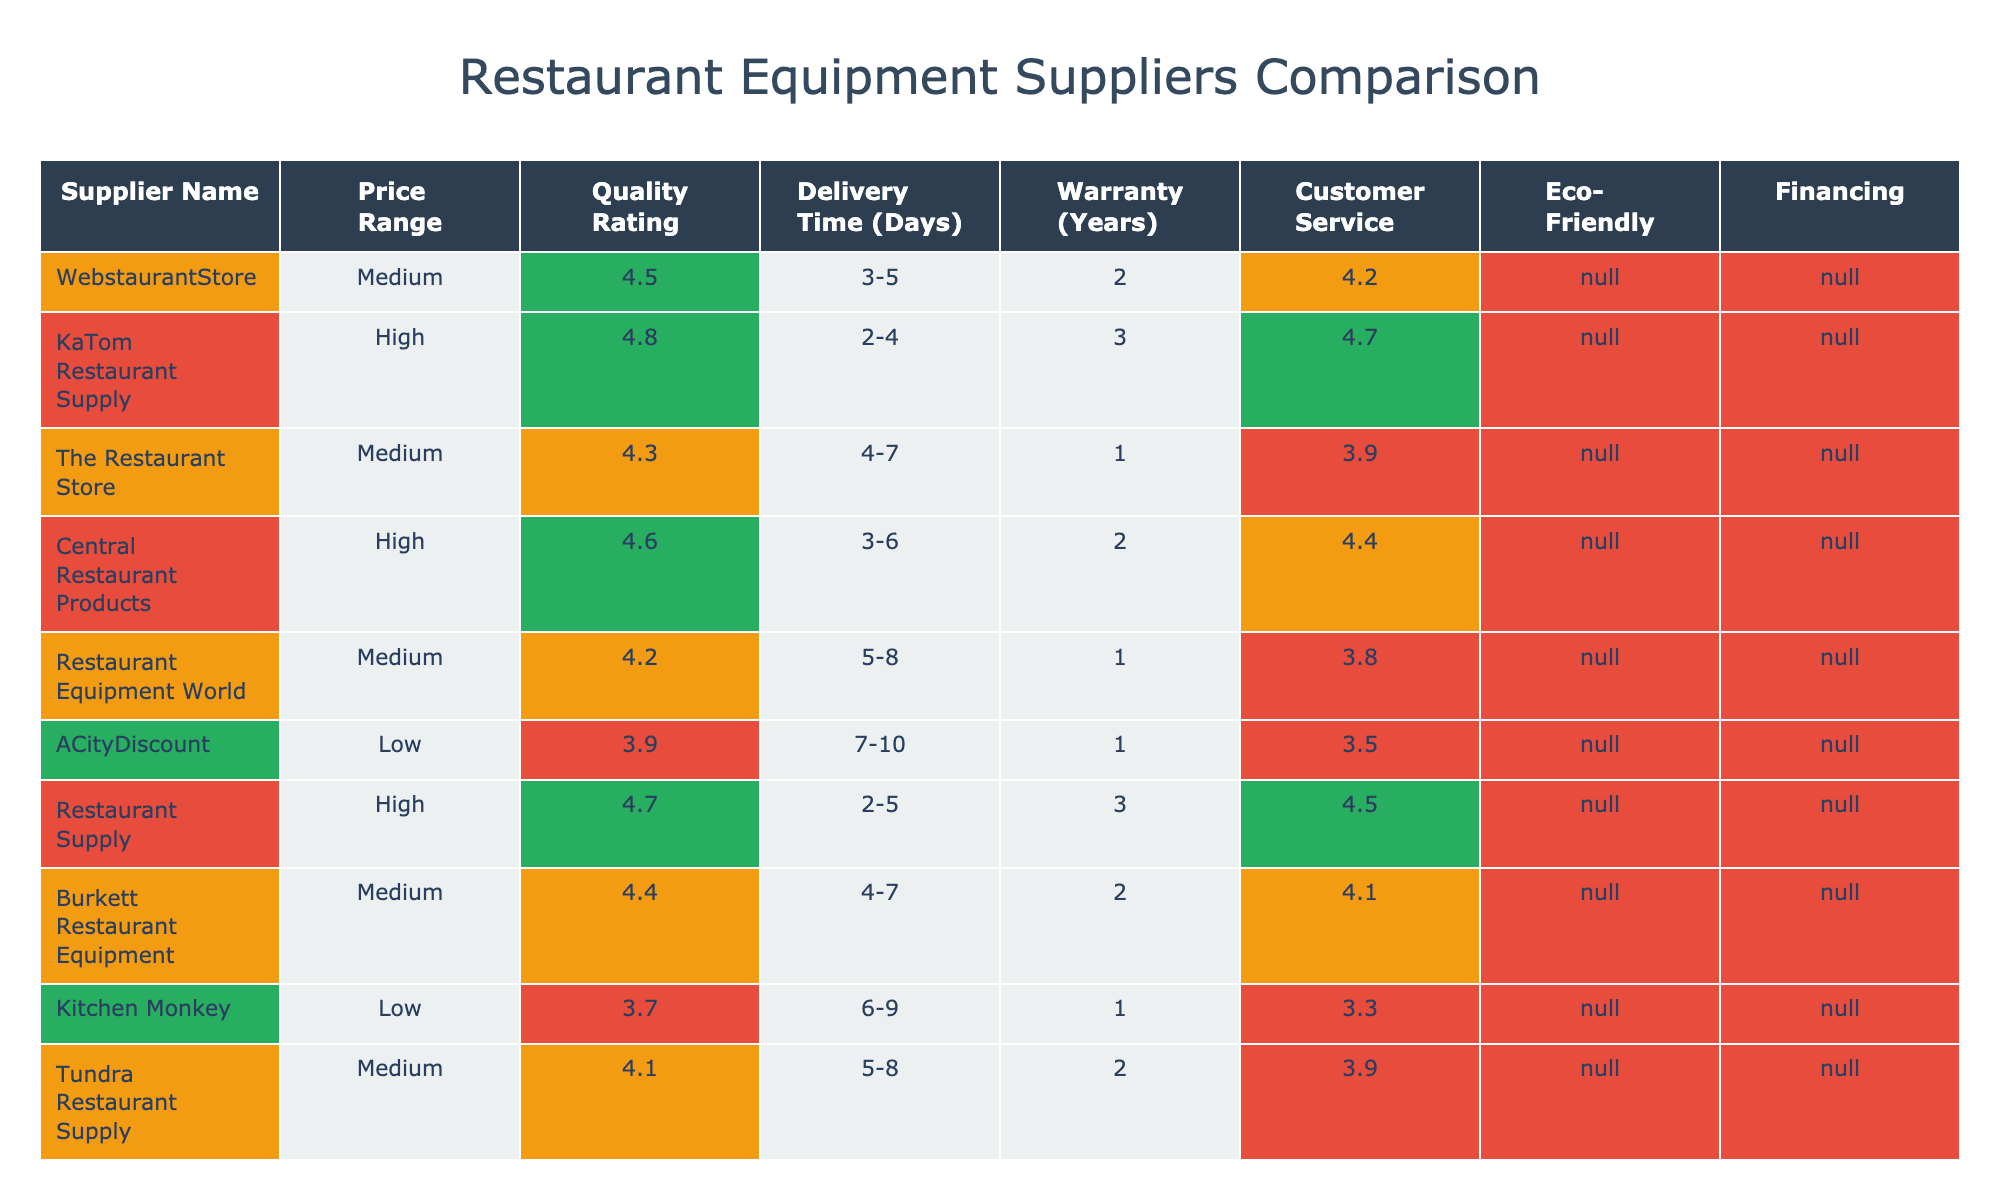What is the quality rating of ACityDiscount? ACityDiscount has a quality rating listed as 3.9 in the table. This value is directly found in the "Quality Rating" column corresponding to the "Supplier Name" ACityDiscount.
Answer: 3.9 Which supplier has the highest customer service rating? By reviewing the "Customer Service Rating" column in the table, KaTom Restaurant Supply has the highest rating at 4.7. This was determined by comparing all values in that column.
Answer: KaTom Restaurant Supply What is the average delivery time for suppliers with eco-friendly options? To find the average delivery time for suppliers with eco-friendly options, we first identify those suppliers: WebstaurantStore, KaTom Restaurant Supply, Central Restaurant Products, Restaurant Supply, Burkett Restaurant Equipment, Tundra Restaurant Supply, Mission Restaurant Supply, Globe Equipment Company. Their delivery times are 4, 3, 4.5 (averaged from 3-6), 3.5 (averaged from 2-5), 4.5, 6.5 (averaged from 5-8), 4.5, and 3.5 (averaged from 2-5). Adding these up (4 + 3 + 4.5 + 3.5 + 4.5 + 6.5 + 4.5 + 3.5 = 34) and dividing by 8 yields an average of 4.25 days.
Answer: 4.25 Which suppliers offer financing? To find which suppliers offer financing, I looked for "Yes" in the "Financing" column. The suppliers offering financing are WebstaurantStore, KaTom Restaurant Supply, Central Restaurant Products, Restaurant Supply, Burkett Restaurant Equipment, Chef's Deal Restaurant Equipment, Mission Restaurant Supply, and Globe Equipment Company.
Answer: 8 suppliers Is the quality rating of Kitchen Monkey above 4.0? Kitchen Monkey has a quality rating of 3.7, which is below 4.0. This value can be checked directly in the "Quality Rating" column corresponding to Kitchen Monkey.
Answer: No What is the difference between the highest and lowest average price range among the suppliers? The highest average price range is from suppliers with "$$$" and the lowest is from those with "$". Since we can rank their price ranges, the difference in the average rating of "$" is lower than "$$$". Thus, if we consider quality ratings average for these sections, we can observe the clear variation in their quality versus the price range they offer. The absolute price difference is not a number but rather how those ranges affect supplier choices.
Answer: Difference is in price range (Low to High) Which supplier has both a high quality rating and low price range? I can check the table for suppliers that have a quality rating of 4.0 or above while having a price range of "$" or "$$". From the list, Burkett Restaurant Equipment with a rating of 4.4 meets this criteria, categorized as "$$". Other suppliers like WebstaurantStore also meet the quality rating but with the same price range maintains a justification within expected versus actual range offerings for low price quality suppliers.
Answer: Burkett Restaurant Equipment What is the warranty period for the supplier with the longest delivery time? Among the suppliers listed, the one with the longest delivery time (7-10 days) is ACityDiscount, which has a warranty of 1 year according to the table. To determine this, I checked the "Delivery Time (Days)" column for the maximum value, then referenced the "Warranty (Years)" column for that specific supplier.
Answer: 1 year 